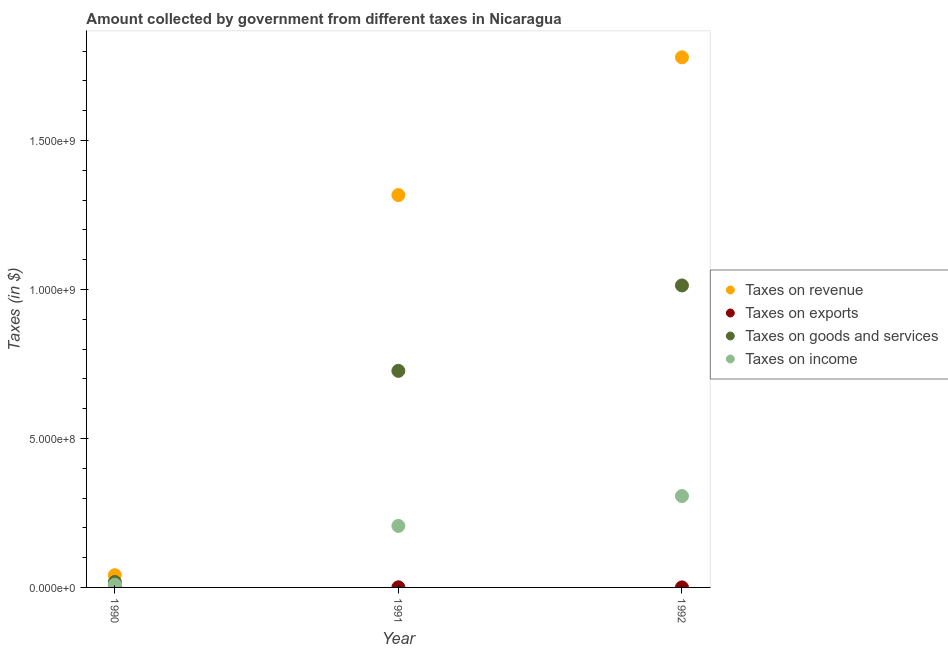What is the amount collected as tax on exports in 1991?
Provide a succinct answer. 3.60e+05. Across all years, what is the maximum amount collected as tax on income?
Your answer should be very brief. 3.07e+08. Across all years, what is the minimum amount collected as tax on exports?
Make the answer very short. 7000. In which year was the amount collected as tax on revenue maximum?
Provide a short and direct response. 1992. In which year was the amount collected as tax on exports minimum?
Ensure brevity in your answer.  1990. What is the total amount collected as tax on goods in the graph?
Ensure brevity in your answer.  1.76e+09. What is the difference between the amount collected as tax on exports in 1990 and that in 1991?
Offer a terse response. -3.53e+05. What is the difference between the amount collected as tax on exports in 1990 and the amount collected as tax on revenue in 1992?
Offer a terse response. -1.78e+09. What is the average amount collected as tax on goods per year?
Your answer should be very brief. 5.86e+08. In the year 1992, what is the difference between the amount collected as tax on revenue and amount collected as tax on exports?
Provide a succinct answer. 1.78e+09. What is the ratio of the amount collected as tax on exports in 1990 to that in 1991?
Give a very brief answer. 0.02. What is the difference between the highest and the second highest amount collected as tax on income?
Keep it short and to the point. 1.00e+08. What is the difference between the highest and the lowest amount collected as tax on income?
Your answer should be very brief. 2.98e+08. In how many years, is the amount collected as tax on revenue greater than the average amount collected as tax on revenue taken over all years?
Your answer should be compact. 2. Is it the case that in every year, the sum of the amount collected as tax on income and amount collected as tax on revenue is greater than the sum of amount collected as tax on goods and amount collected as tax on exports?
Provide a short and direct response. No. Does the amount collected as tax on goods monotonically increase over the years?
Your answer should be compact. Yes. Is the amount collected as tax on goods strictly greater than the amount collected as tax on income over the years?
Keep it short and to the point. Yes. How many dotlines are there?
Keep it short and to the point. 4. How many years are there in the graph?
Your response must be concise. 3. What is the difference between two consecutive major ticks on the Y-axis?
Make the answer very short. 5.00e+08. Does the graph contain grids?
Keep it short and to the point. No. How many legend labels are there?
Offer a very short reply. 4. What is the title of the graph?
Make the answer very short. Amount collected by government from different taxes in Nicaragua. What is the label or title of the Y-axis?
Provide a succinct answer. Taxes (in $). What is the Taxes (in $) of Taxes on revenue in 1990?
Your answer should be very brief. 4.11e+07. What is the Taxes (in $) in Taxes on exports in 1990?
Your response must be concise. 7000. What is the Taxes (in $) in Taxes on goods and services in 1990?
Your answer should be compact. 1.82e+07. What is the Taxes (in $) in Taxes on income in 1990?
Offer a very short reply. 9.16e+06. What is the Taxes (in $) of Taxes on revenue in 1991?
Make the answer very short. 1.32e+09. What is the Taxes (in $) of Taxes on exports in 1991?
Your answer should be compact. 3.60e+05. What is the Taxes (in $) in Taxes on goods and services in 1991?
Make the answer very short. 7.27e+08. What is the Taxes (in $) in Taxes on income in 1991?
Ensure brevity in your answer.  2.06e+08. What is the Taxes (in $) in Taxes on revenue in 1992?
Your answer should be very brief. 1.78e+09. What is the Taxes (in $) in Taxes on goods and services in 1992?
Offer a very short reply. 1.01e+09. What is the Taxes (in $) in Taxes on income in 1992?
Keep it short and to the point. 3.07e+08. Across all years, what is the maximum Taxes (in $) in Taxes on revenue?
Your response must be concise. 1.78e+09. Across all years, what is the maximum Taxes (in $) of Taxes on goods and services?
Keep it short and to the point. 1.01e+09. Across all years, what is the maximum Taxes (in $) in Taxes on income?
Your answer should be compact. 3.07e+08. Across all years, what is the minimum Taxes (in $) of Taxes on revenue?
Offer a very short reply. 4.11e+07. Across all years, what is the minimum Taxes (in $) in Taxes on exports?
Provide a short and direct response. 7000. Across all years, what is the minimum Taxes (in $) in Taxes on goods and services?
Your answer should be very brief. 1.82e+07. Across all years, what is the minimum Taxes (in $) of Taxes on income?
Ensure brevity in your answer.  9.16e+06. What is the total Taxes (in $) in Taxes on revenue in the graph?
Your answer should be very brief. 3.14e+09. What is the total Taxes (in $) in Taxes on exports in the graph?
Make the answer very short. 4.67e+05. What is the total Taxes (in $) of Taxes on goods and services in the graph?
Give a very brief answer. 1.76e+09. What is the total Taxes (in $) in Taxes on income in the graph?
Ensure brevity in your answer.  5.22e+08. What is the difference between the Taxes (in $) in Taxes on revenue in 1990 and that in 1991?
Keep it short and to the point. -1.28e+09. What is the difference between the Taxes (in $) in Taxes on exports in 1990 and that in 1991?
Ensure brevity in your answer.  -3.53e+05. What is the difference between the Taxes (in $) of Taxes on goods and services in 1990 and that in 1991?
Offer a terse response. -7.09e+08. What is the difference between the Taxes (in $) in Taxes on income in 1990 and that in 1991?
Offer a terse response. -1.97e+08. What is the difference between the Taxes (in $) in Taxes on revenue in 1990 and that in 1992?
Offer a very short reply. -1.74e+09. What is the difference between the Taxes (in $) in Taxes on exports in 1990 and that in 1992?
Provide a succinct answer. -9.30e+04. What is the difference between the Taxes (in $) in Taxes on goods and services in 1990 and that in 1992?
Your answer should be very brief. -9.95e+08. What is the difference between the Taxes (in $) of Taxes on income in 1990 and that in 1992?
Keep it short and to the point. -2.98e+08. What is the difference between the Taxes (in $) of Taxes on revenue in 1991 and that in 1992?
Your answer should be compact. -4.62e+08. What is the difference between the Taxes (in $) in Taxes on exports in 1991 and that in 1992?
Your answer should be compact. 2.60e+05. What is the difference between the Taxes (in $) in Taxes on goods and services in 1991 and that in 1992?
Give a very brief answer. -2.87e+08. What is the difference between the Taxes (in $) in Taxes on income in 1991 and that in 1992?
Your answer should be compact. -1.00e+08. What is the difference between the Taxes (in $) of Taxes on revenue in 1990 and the Taxes (in $) of Taxes on exports in 1991?
Ensure brevity in your answer.  4.07e+07. What is the difference between the Taxes (in $) of Taxes on revenue in 1990 and the Taxes (in $) of Taxes on goods and services in 1991?
Ensure brevity in your answer.  -6.86e+08. What is the difference between the Taxes (in $) of Taxes on revenue in 1990 and the Taxes (in $) of Taxes on income in 1991?
Your response must be concise. -1.65e+08. What is the difference between the Taxes (in $) of Taxes on exports in 1990 and the Taxes (in $) of Taxes on goods and services in 1991?
Provide a short and direct response. -7.27e+08. What is the difference between the Taxes (in $) of Taxes on exports in 1990 and the Taxes (in $) of Taxes on income in 1991?
Your answer should be very brief. -2.06e+08. What is the difference between the Taxes (in $) in Taxes on goods and services in 1990 and the Taxes (in $) in Taxes on income in 1991?
Your answer should be very brief. -1.88e+08. What is the difference between the Taxes (in $) of Taxes on revenue in 1990 and the Taxes (in $) of Taxes on exports in 1992?
Provide a short and direct response. 4.10e+07. What is the difference between the Taxes (in $) of Taxes on revenue in 1990 and the Taxes (in $) of Taxes on goods and services in 1992?
Give a very brief answer. -9.73e+08. What is the difference between the Taxes (in $) of Taxes on revenue in 1990 and the Taxes (in $) of Taxes on income in 1992?
Provide a succinct answer. -2.66e+08. What is the difference between the Taxes (in $) in Taxes on exports in 1990 and the Taxes (in $) in Taxes on goods and services in 1992?
Ensure brevity in your answer.  -1.01e+09. What is the difference between the Taxes (in $) of Taxes on exports in 1990 and the Taxes (in $) of Taxes on income in 1992?
Offer a terse response. -3.07e+08. What is the difference between the Taxes (in $) in Taxes on goods and services in 1990 and the Taxes (in $) in Taxes on income in 1992?
Keep it short and to the point. -2.89e+08. What is the difference between the Taxes (in $) in Taxes on revenue in 1991 and the Taxes (in $) in Taxes on exports in 1992?
Provide a succinct answer. 1.32e+09. What is the difference between the Taxes (in $) in Taxes on revenue in 1991 and the Taxes (in $) in Taxes on goods and services in 1992?
Give a very brief answer. 3.03e+08. What is the difference between the Taxes (in $) in Taxes on revenue in 1991 and the Taxes (in $) in Taxes on income in 1992?
Your answer should be compact. 1.01e+09. What is the difference between the Taxes (in $) in Taxes on exports in 1991 and the Taxes (in $) in Taxes on goods and services in 1992?
Your answer should be compact. -1.01e+09. What is the difference between the Taxes (in $) in Taxes on exports in 1991 and the Taxes (in $) in Taxes on income in 1992?
Keep it short and to the point. -3.06e+08. What is the difference between the Taxes (in $) of Taxes on goods and services in 1991 and the Taxes (in $) of Taxes on income in 1992?
Your response must be concise. 4.20e+08. What is the average Taxes (in $) of Taxes on revenue per year?
Give a very brief answer. 1.05e+09. What is the average Taxes (in $) in Taxes on exports per year?
Offer a terse response. 1.56e+05. What is the average Taxes (in $) of Taxes on goods and services per year?
Your response must be concise. 5.86e+08. What is the average Taxes (in $) of Taxes on income per year?
Give a very brief answer. 1.74e+08. In the year 1990, what is the difference between the Taxes (in $) in Taxes on revenue and Taxes (in $) in Taxes on exports?
Make the answer very short. 4.11e+07. In the year 1990, what is the difference between the Taxes (in $) in Taxes on revenue and Taxes (in $) in Taxes on goods and services?
Keep it short and to the point. 2.29e+07. In the year 1990, what is the difference between the Taxes (in $) of Taxes on revenue and Taxes (in $) of Taxes on income?
Your answer should be compact. 3.19e+07. In the year 1990, what is the difference between the Taxes (in $) of Taxes on exports and Taxes (in $) of Taxes on goods and services?
Your response must be concise. -1.82e+07. In the year 1990, what is the difference between the Taxes (in $) in Taxes on exports and Taxes (in $) in Taxes on income?
Provide a succinct answer. -9.15e+06. In the year 1990, what is the difference between the Taxes (in $) in Taxes on goods and services and Taxes (in $) in Taxes on income?
Offer a terse response. 9.02e+06. In the year 1991, what is the difference between the Taxes (in $) of Taxes on revenue and Taxes (in $) of Taxes on exports?
Provide a succinct answer. 1.32e+09. In the year 1991, what is the difference between the Taxes (in $) of Taxes on revenue and Taxes (in $) of Taxes on goods and services?
Keep it short and to the point. 5.90e+08. In the year 1991, what is the difference between the Taxes (in $) in Taxes on revenue and Taxes (in $) in Taxes on income?
Provide a short and direct response. 1.11e+09. In the year 1991, what is the difference between the Taxes (in $) in Taxes on exports and Taxes (in $) in Taxes on goods and services?
Your response must be concise. -7.27e+08. In the year 1991, what is the difference between the Taxes (in $) of Taxes on exports and Taxes (in $) of Taxes on income?
Make the answer very short. -2.06e+08. In the year 1991, what is the difference between the Taxes (in $) in Taxes on goods and services and Taxes (in $) in Taxes on income?
Your answer should be compact. 5.21e+08. In the year 1992, what is the difference between the Taxes (in $) of Taxes on revenue and Taxes (in $) of Taxes on exports?
Your response must be concise. 1.78e+09. In the year 1992, what is the difference between the Taxes (in $) of Taxes on revenue and Taxes (in $) of Taxes on goods and services?
Your answer should be compact. 7.66e+08. In the year 1992, what is the difference between the Taxes (in $) of Taxes on revenue and Taxes (in $) of Taxes on income?
Your response must be concise. 1.47e+09. In the year 1992, what is the difference between the Taxes (in $) in Taxes on exports and Taxes (in $) in Taxes on goods and services?
Your answer should be compact. -1.01e+09. In the year 1992, what is the difference between the Taxes (in $) of Taxes on exports and Taxes (in $) of Taxes on income?
Keep it short and to the point. -3.07e+08. In the year 1992, what is the difference between the Taxes (in $) in Taxes on goods and services and Taxes (in $) in Taxes on income?
Offer a very short reply. 7.07e+08. What is the ratio of the Taxes (in $) of Taxes on revenue in 1990 to that in 1991?
Ensure brevity in your answer.  0.03. What is the ratio of the Taxes (in $) in Taxes on exports in 1990 to that in 1991?
Give a very brief answer. 0.02. What is the ratio of the Taxes (in $) of Taxes on goods and services in 1990 to that in 1991?
Your response must be concise. 0.03. What is the ratio of the Taxes (in $) of Taxes on income in 1990 to that in 1991?
Your response must be concise. 0.04. What is the ratio of the Taxes (in $) of Taxes on revenue in 1990 to that in 1992?
Your response must be concise. 0.02. What is the ratio of the Taxes (in $) of Taxes on exports in 1990 to that in 1992?
Your answer should be very brief. 0.07. What is the ratio of the Taxes (in $) of Taxes on goods and services in 1990 to that in 1992?
Ensure brevity in your answer.  0.02. What is the ratio of the Taxes (in $) of Taxes on income in 1990 to that in 1992?
Provide a succinct answer. 0.03. What is the ratio of the Taxes (in $) in Taxes on revenue in 1991 to that in 1992?
Your answer should be very brief. 0.74. What is the ratio of the Taxes (in $) in Taxes on goods and services in 1991 to that in 1992?
Offer a terse response. 0.72. What is the ratio of the Taxes (in $) in Taxes on income in 1991 to that in 1992?
Your answer should be very brief. 0.67. What is the difference between the highest and the second highest Taxes (in $) of Taxes on revenue?
Keep it short and to the point. 4.62e+08. What is the difference between the highest and the second highest Taxes (in $) of Taxes on exports?
Your answer should be very brief. 2.60e+05. What is the difference between the highest and the second highest Taxes (in $) in Taxes on goods and services?
Provide a short and direct response. 2.87e+08. What is the difference between the highest and the second highest Taxes (in $) in Taxes on income?
Offer a terse response. 1.00e+08. What is the difference between the highest and the lowest Taxes (in $) of Taxes on revenue?
Keep it short and to the point. 1.74e+09. What is the difference between the highest and the lowest Taxes (in $) of Taxes on exports?
Your response must be concise. 3.53e+05. What is the difference between the highest and the lowest Taxes (in $) of Taxes on goods and services?
Provide a succinct answer. 9.95e+08. What is the difference between the highest and the lowest Taxes (in $) of Taxes on income?
Provide a succinct answer. 2.98e+08. 